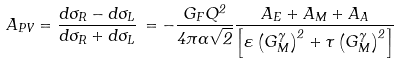Convert formula to latex. <formula><loc_0><loc_0><loc_500><loc_500>A _ { P V } = \frac { d \sigma _ { R } - d \sigma _ { L } } { d \sigma _ { R } + d \sigma _ { L } } \, = - \frac { G _ { F } Q ^ { 2 } } { 4 \pi \alpha \sqrt { 2 } } \frac { A _ { E } + A _ { M } + A _ { A } } { \left [ \varepsilon \left ( G _ { M } ^ { \gamma } \right ) ^ { 2 } + \tau \left ( G _ { M } ^ { \gamma } \right ) ^ { 2 } \right ] }</formula> 